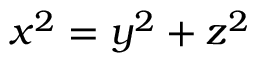<formula> <loc_0><loc_0><loc_500><loc_500>x ^ { 2 } = y ^ { 2 } + z ^ { 2 }</formula> 